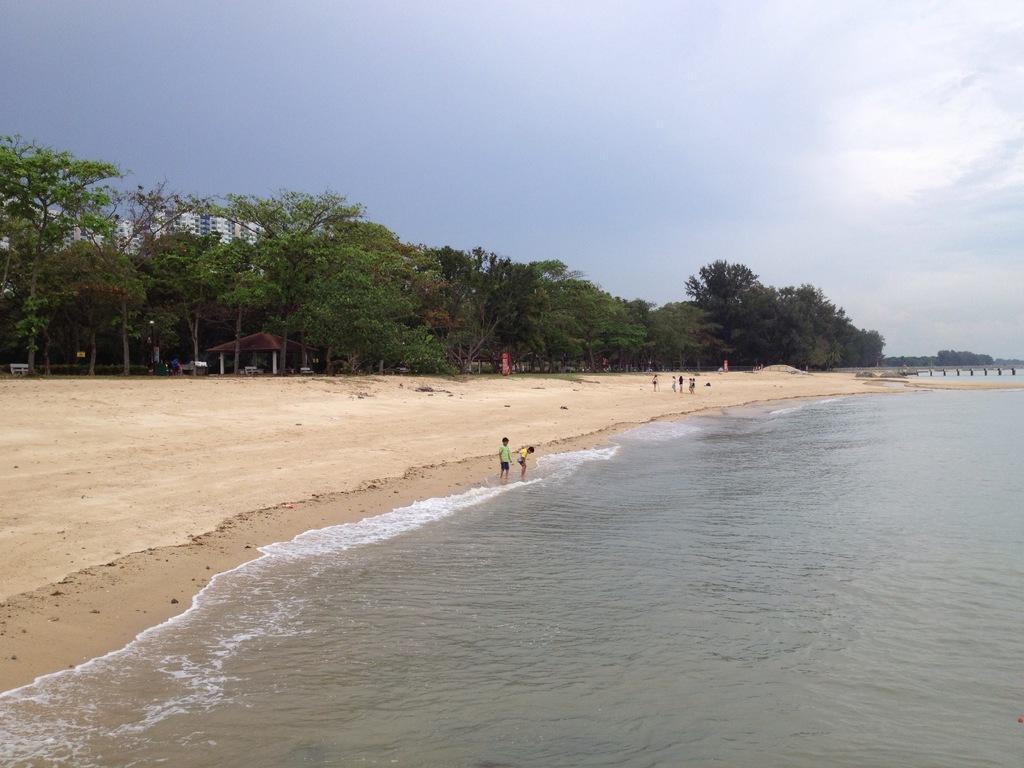Can you describe this image briefly? In the foreground of this picture, there is a beach where we can see water, sand, trees, buildings and the sky. 